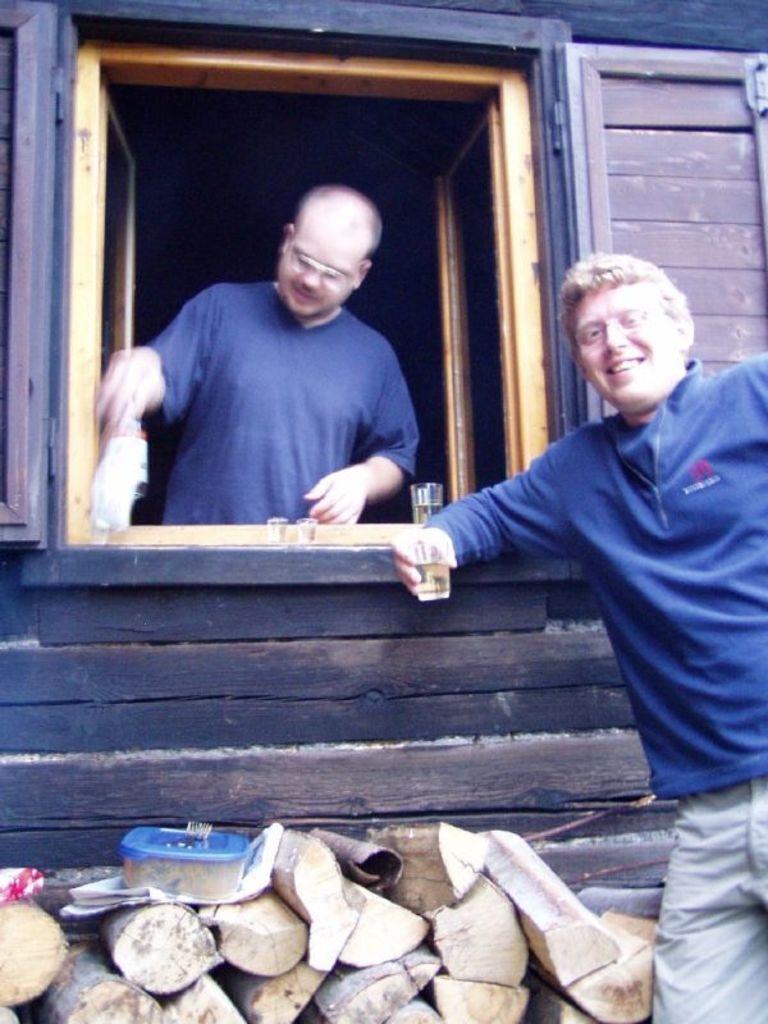In one or two sentences, can you explain what this image depicts? In the center of the image we can see a person standing at the window with glasses. On the right side of the image we can see a person standing with glass. At the bottom there are wooden sticks. 